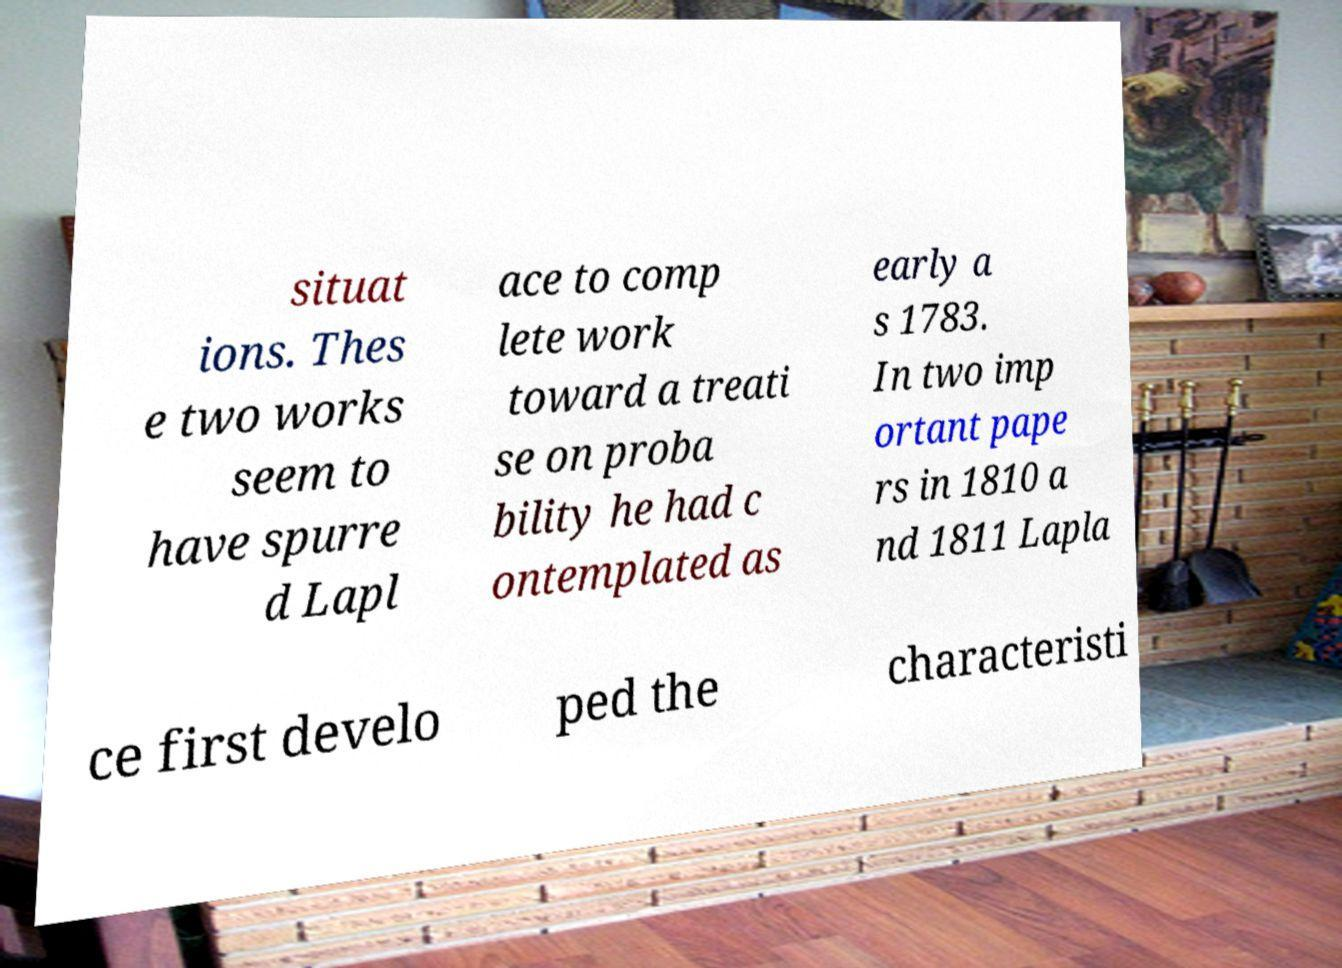For documentation purposes, I need the text within this image transcribed. Could you provide that? situat ions. Thes e two works seem to have spurre d Lapl ace to comp lete work toward a treati se on proba bility he had c ontemplated as early a s 1783. In two imp ortant pape rs in 1810 a nd 1811 Lapla ce first develo ped the characteristi 